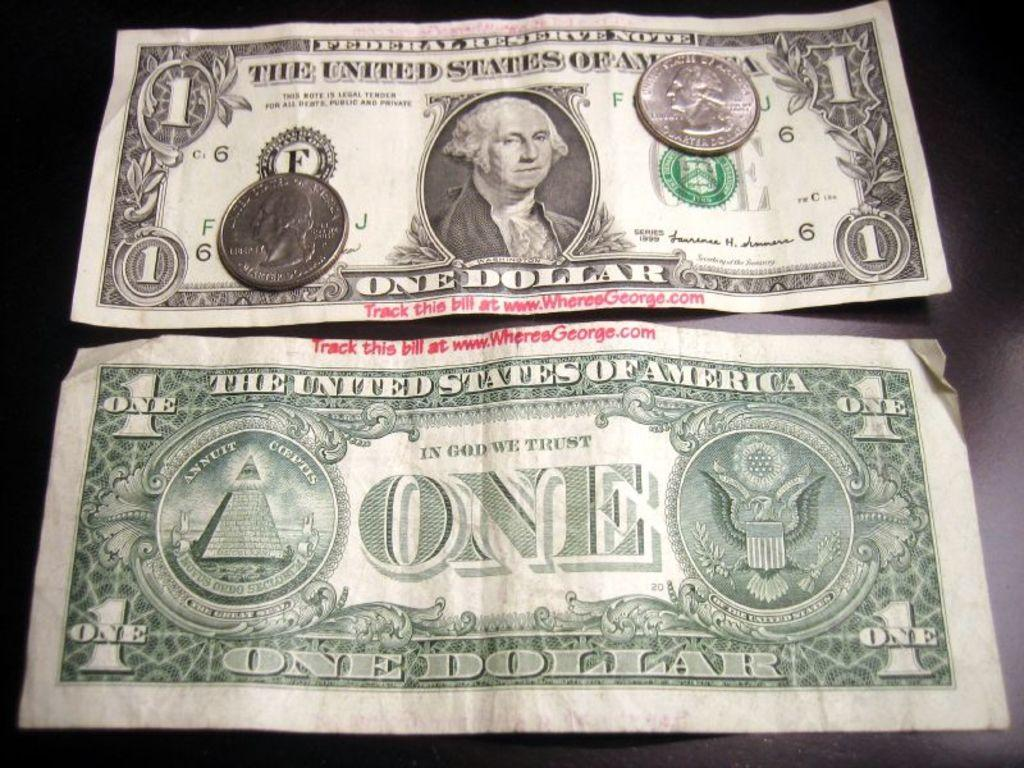What type of money is visible in the image? There are currency notes and coins in the image. Where are the currency notes and coins located? The currency notes and coins are on a surface in the image. What type of watch is visible on the currency notes in the image? There is no watch visible on the currency notes in the image. What part of the currency notes is missing in the image? There is no indication that any part of the currency notes is missing in the image. 